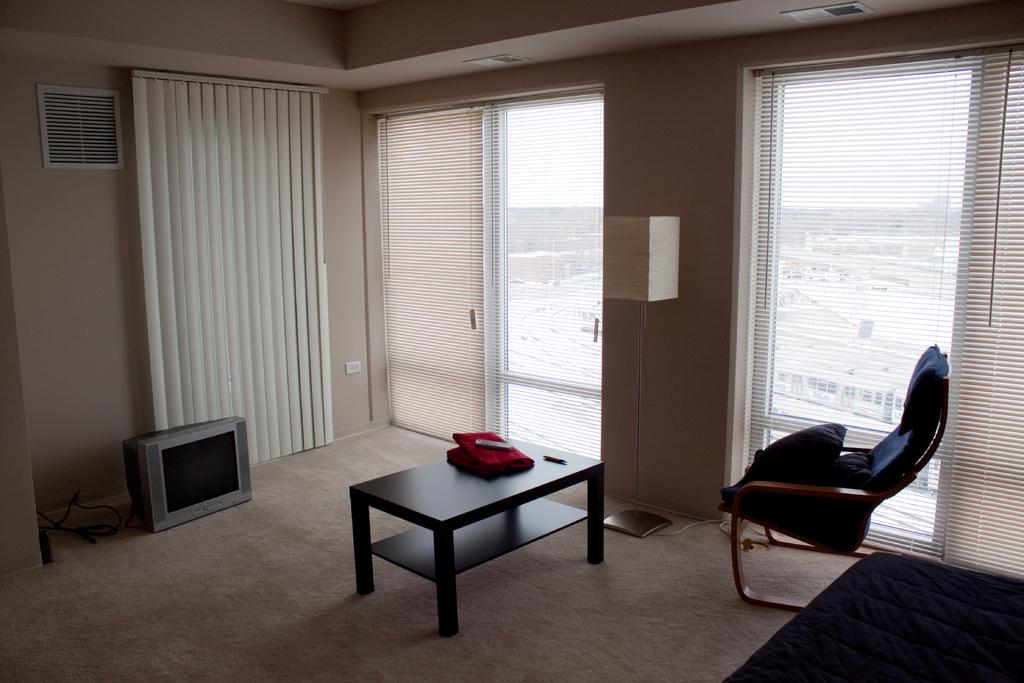What type of space is depicted in the image? There is a room in the image. What electronic device can be seen in the room? There is a TV in the room. What piece of furniture is present for placing objects or eating? There is a table in the room. What type of seating is available in the room? There is a chair in the room. What type of dress is hanging in the room in the image? There is no dress present in the image; only a room, TV, table, and chair are visible. 